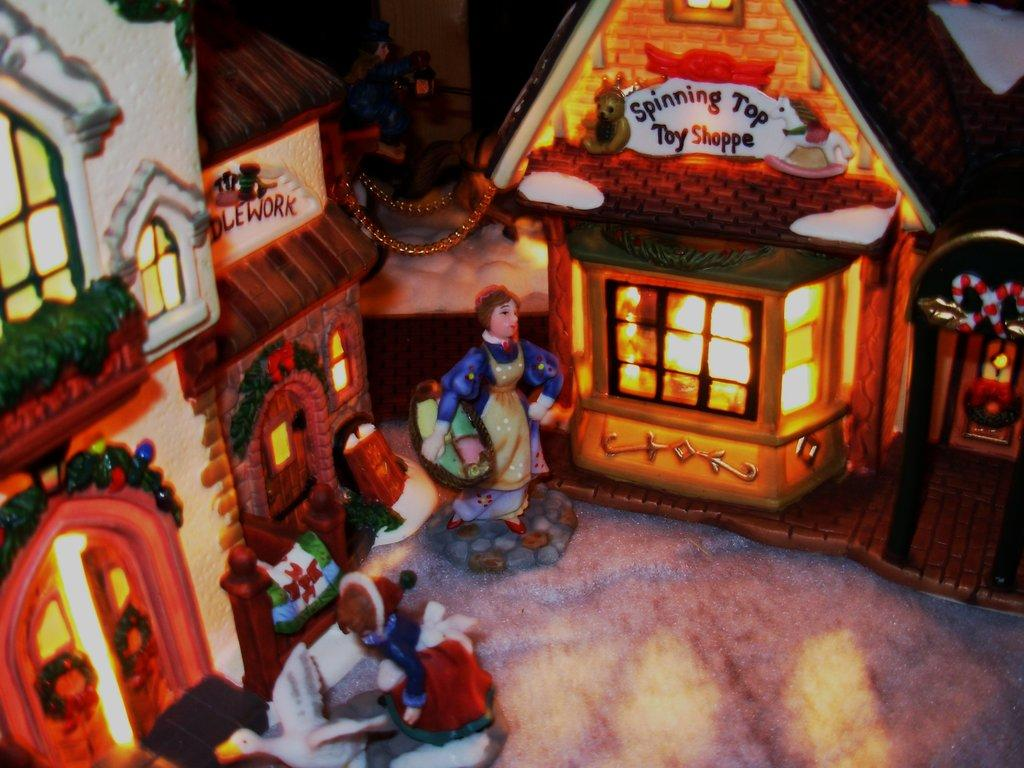What type of structures are shown in the image? There are houses depicted in the image. What natural phenomenon is depicted in the image? There is lightning depicted in the image. Are there any living beings shown in the image? Yes, there are people and a bird depicted in the image. What type of path is shown in the image? There is a path depicted in the image. What type of rod is used to stir the bird in the image? There is no rod present in the image, and the bird is not being stirred. What is the interest rate for the houses depicted in the image? The provided facts do not mention any interest rates, so this information cannot be determined from the image. 